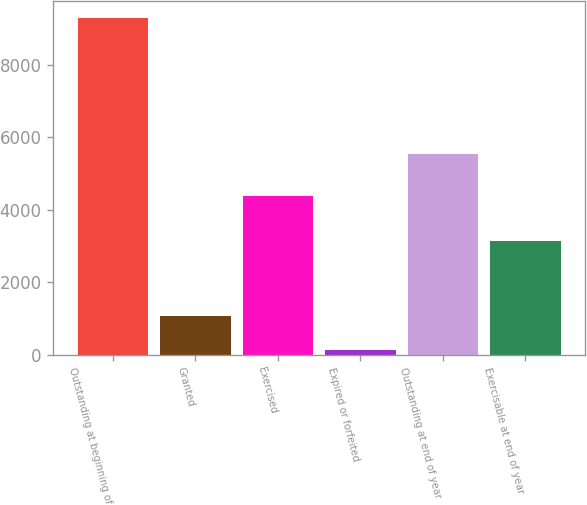Convert chart. <chart><loc_0><loc_0><loc_500><loc_500><bar_chart><fcel>Outstanding at beginning of<fcel>Granted<fcel>Exercised<fcel>Expired or forfeited<fcel>Outstanding at end of year<fcel>Exercisable at end of year<nl><fcel>9283<fcel>1053.4<fcel>4377<fcel>139<fcel>5543<fcel>3144<nl></chart> 